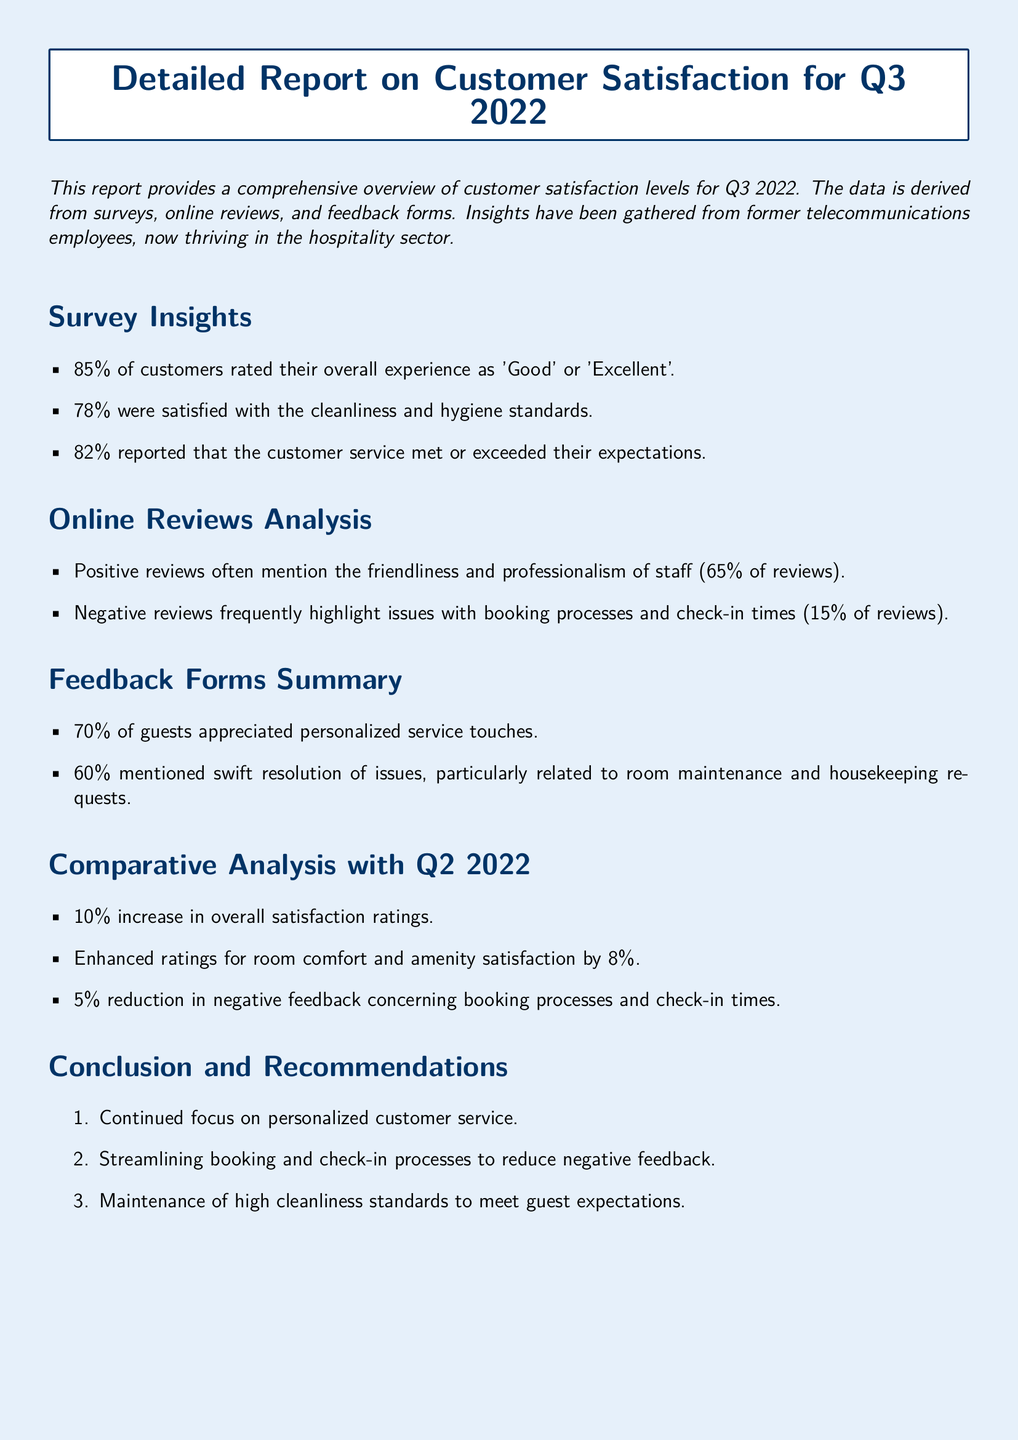What percentage of customers rated their experience as 'Good' or 'Excellent'? The document states that 85% of customers rated their overall experience positively.
Answer: 85% What percentage of guests appreciated personalized service touches? According to the feedback forms summary, 70% of guests appreciated personalized services.
Answer: 70% What was the percentage increase in overall satisfaction ratings compared to Q2 2022? The comparative analysis indicates a 10% increase in overall satisfaction ratings from Q2 2022.
Answer: 10% What were the main issues highlighted in negative reviews? The document specifies that negative reviews often mention booking processes and check-in times.
Answer: Booking processes and check-in times What percentage of customers were satisfied with cleanliness and hygiene? The survey insights reveal that 78% were satisfied with cleanliness and hygiene standards.
Answer: 78% What is the recommendation concerning booking and check-in processes? The conclusion recommends streamlining booking and check-in processes to reduce negative feedback.
Answer: Streamlining booking and check-in processes What percentage of reviews mentioned the friendliness and professionalism of staff? The online reviews analysis states that 65% of reviews mention friendliness and professionalism of staff.
Answer: 65% What was the percentage reduction in negative feedback concerning booking processes and check-in times? The comparative analysis shows a 5% reduction in negative feedback regarding these issues.
Answer: 5% 